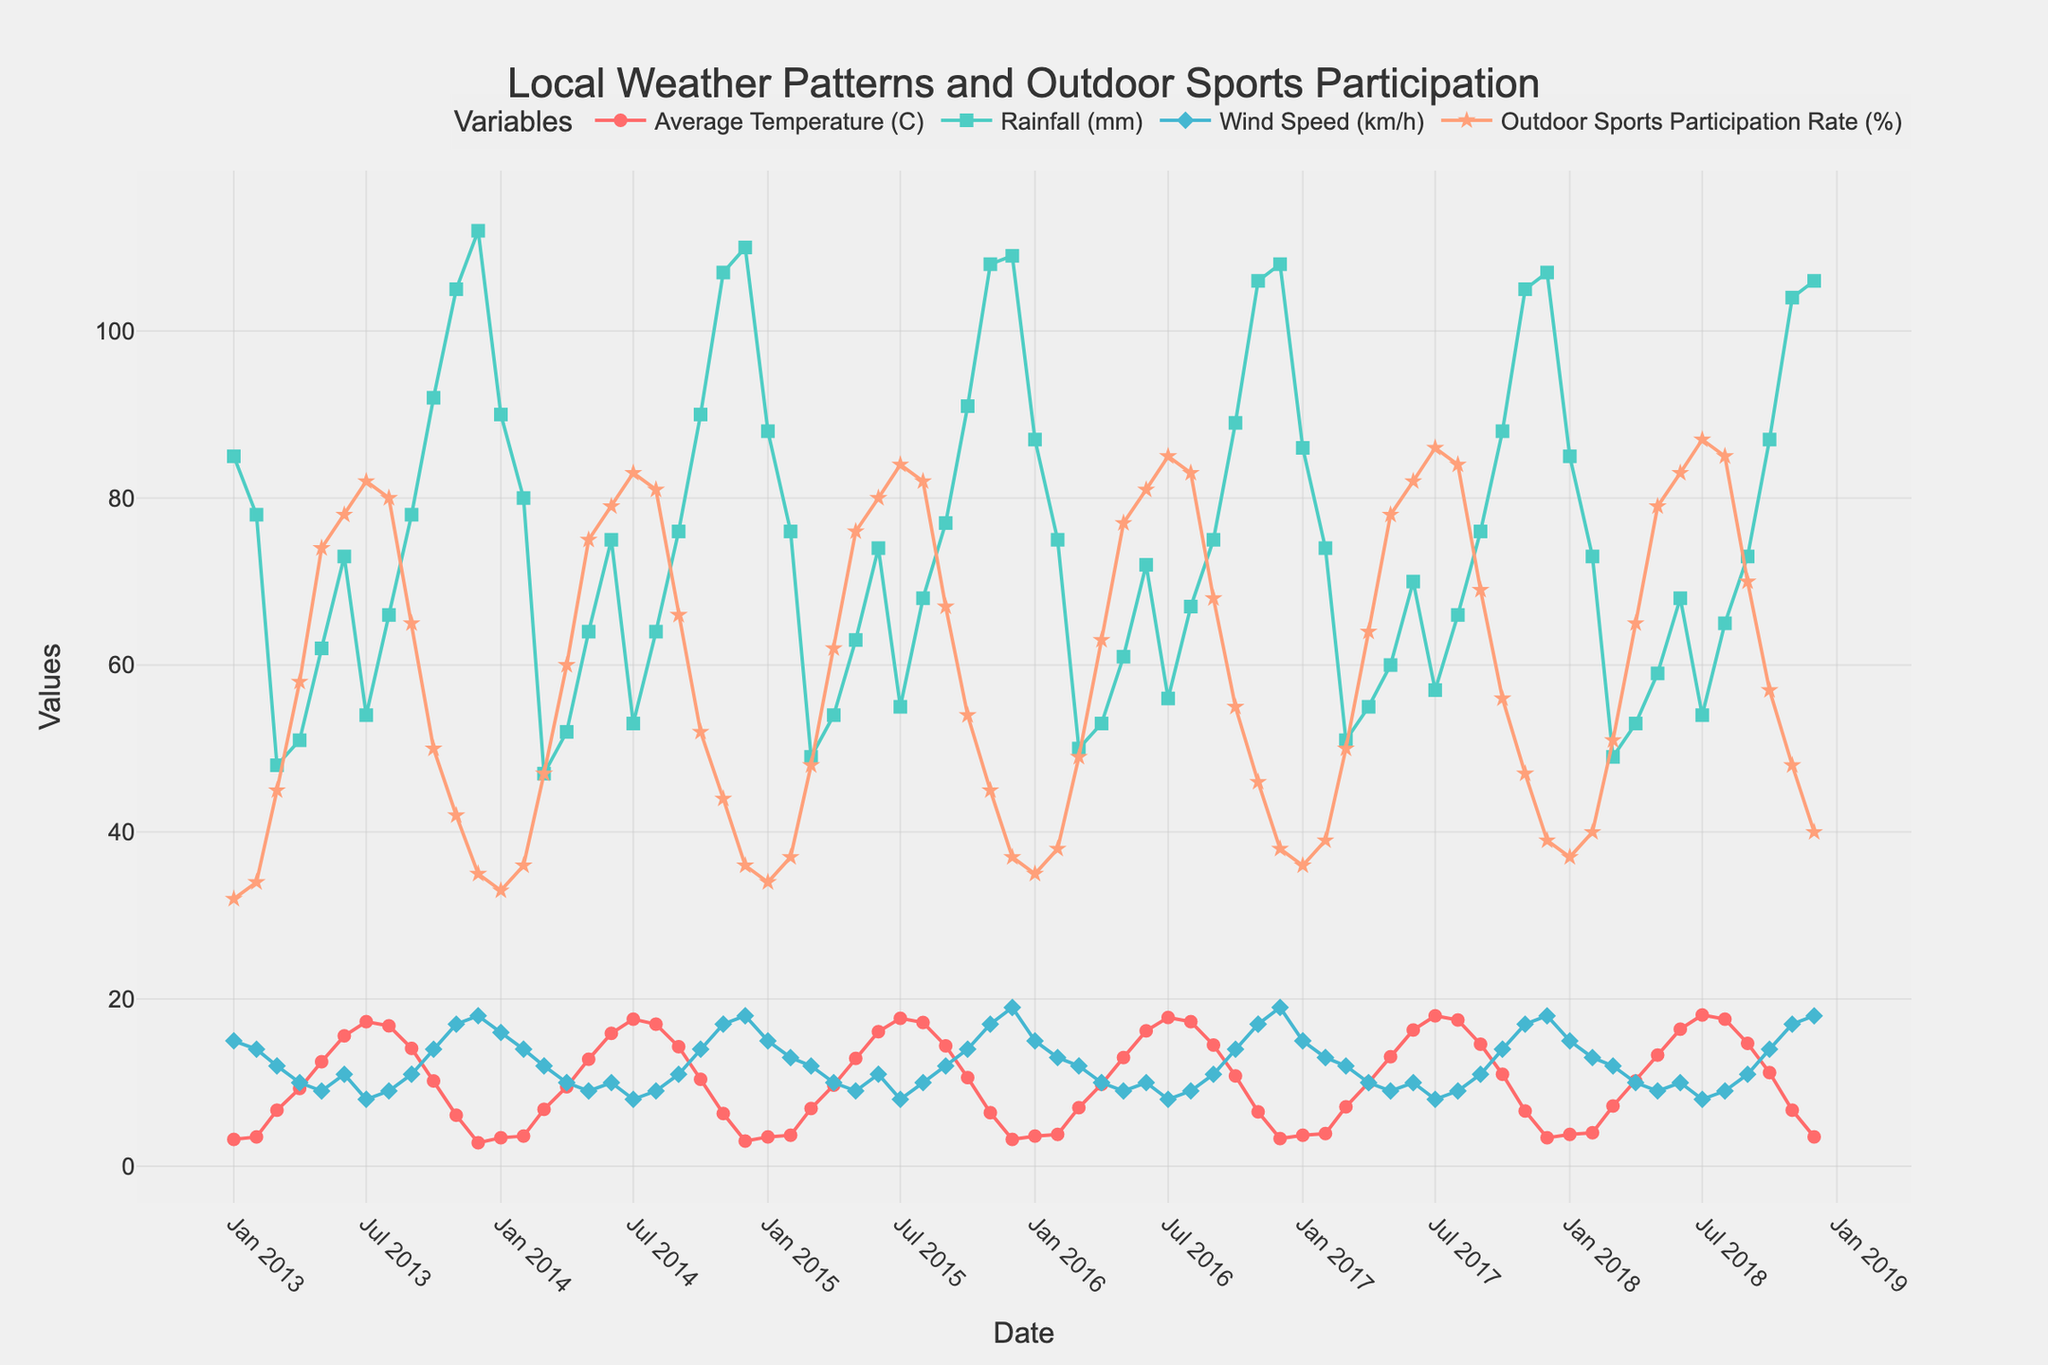What is the title of the figure? The title of the figure is often displayed at the top of the chart to provide a summary of the content. By looking at the figure, we can read the title directly.
Answer: Local Weather Patterns and Outdoor Sports Participation Which variable shows the biggest seasonal changes? By examining the figure and observing the patterns of each variable over different months and years, we can identify which variable has the most variation between seasons.
Answer: Outdoor Sports Participation Rate (%) During which months does the Outdoor Sports Participation Rate (%) typically peak each year? Look for the highest points in the Outdoor Sports Participation Rate (%) trace on the figure for each year. These peaks usually occur during specific months, often in the warmer seasons.
Answer: July What is the relationship between Average Temperature (C) and Outdoor Sports Participation Rate (%)? Analyze the trends of both Average Temperature and Outdoor Sports Participation Rate traces. If the Outdoor Sports Participation increases as the temperature rises, there is a positive correlation.
Answer: Positive correlation On average, how does rainfall in October compare to April over the years? Calculate the average Rainfall (mm) for each October and April, then compare them. This requires visually evaluating the rainfall data points for the specific months over the years.
Answer: October generally has higher rainfall than April Is there any noticeable trend in the Average Temperature (C) over the decade? Observe the Average Temperature (C) trace across the entire time span. If the temperature is increasing, decreasing, or stable, this will indicate the overall trend.
Answer: Slight increase Which year had the lowest Outdoor Sports Participation Rate (%) in December? Identify the data points for December in each year for Outdoor Sports Participation Rate (%) and find the smallest value.
Answer: 2013 How do wind speeds in July compare to January on average? Calculate the average Wind Speed (km/h) for each July and January, then compare these averages. This involves reviewing the wind speed data points for those months over the years.
Answer: July typically has lower wind speeds than January Is there a month where the Outdoor Sports Participation Rate (%) and Rainfall (mm) both peak? Look for a month where both the Outdoor Sports Participation Rate and Rainfall traces reach their highest points simultaneously. This requires comparing both traces across all months.
Answer: No evident peak together In which year did the rainfall peak, and what was the corresponding Outdoor Sports Participation Rate (%) during that peak? Find the highest Rainfall (mm) point on the figure and identify the year. Then, check the Outdoor Sports Participation Rate (%) for the same time period.
Answer: Rainfall peaked in December 2013 with an Outdoor Sports Participation Rate of 35% 